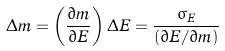Convert formula to latex. <formula><loc_0><loc_0><loc_500><loc_500>\Delta m = \left ( \frac { \partial m } { \partial E } \right ) \Delta E = \frac { \sigma _ { E } } { ( \partial E / \partial m ) }</formula> 